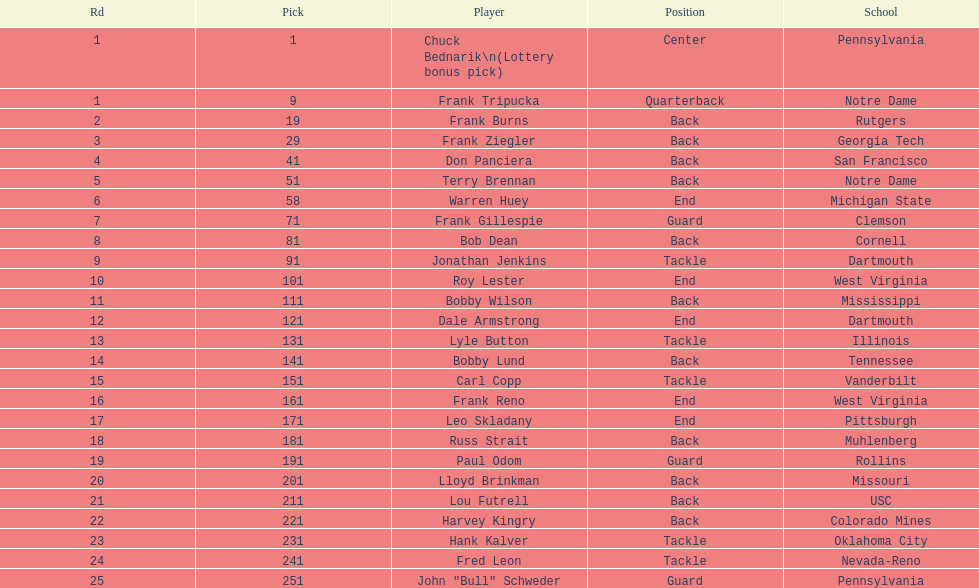Who was selected following roy lester? Bobby Wilson. 